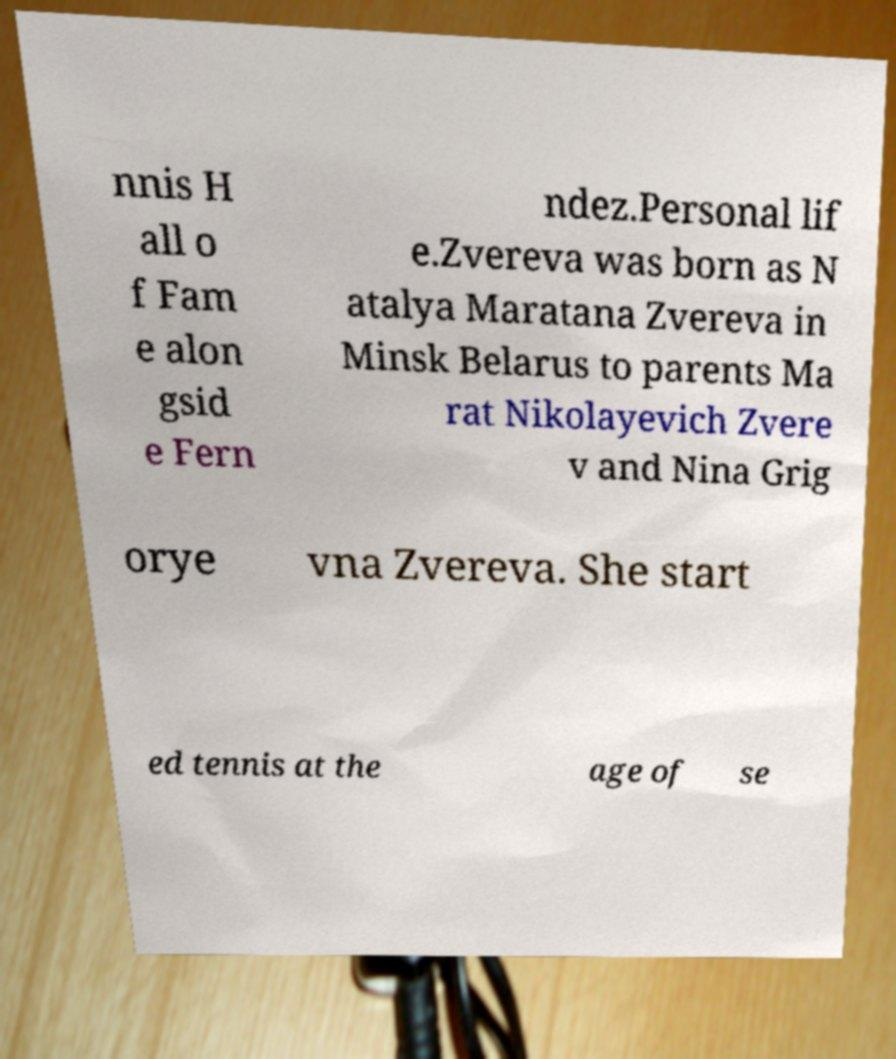Please read and relay the text visible in this image. What does it say? nnis H all o f Fam e alon gsid e Fern ndez.Personal lif e.Zvereva was born as N atalya Maratana Zvereva in Minsk Belarus to parents Ma rat Nikolayevich Zvere v and Nina Grig orye vna Zvereva. She start ed tennis at the age of se 